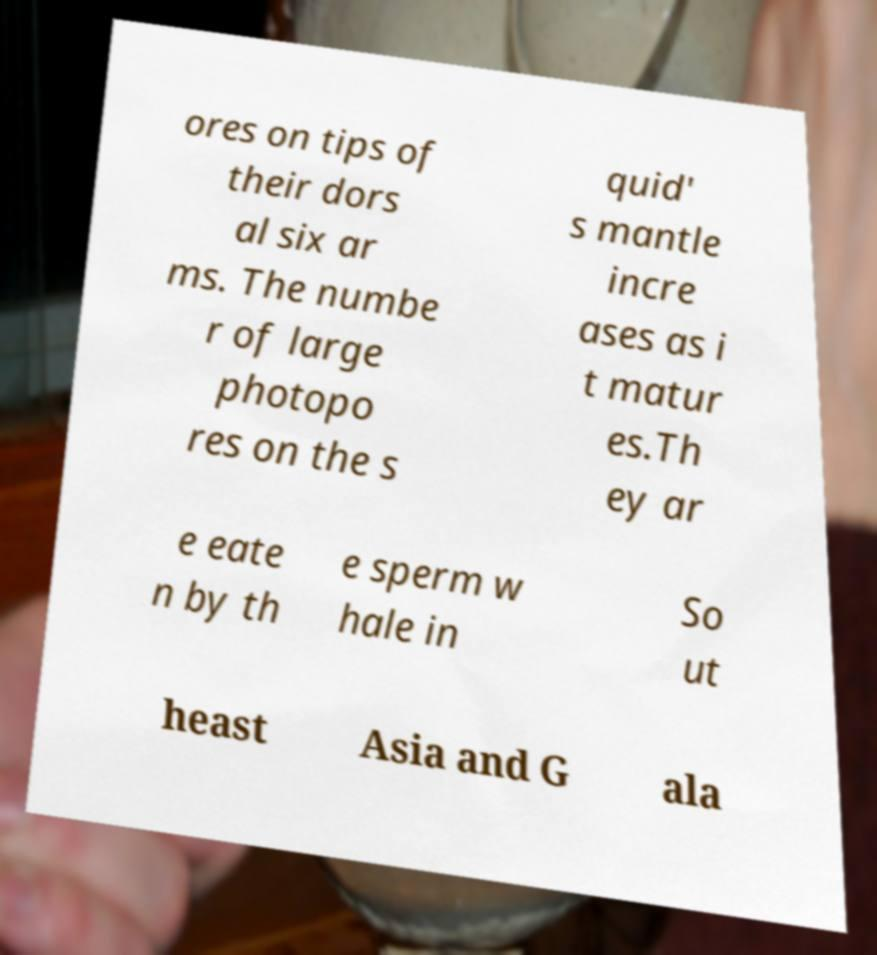Can you read and provide the text displayed in the image?This photo seems to have some interesting text. Can you extract and type it out for me? ores on tips of their dors al six ar ms. The numbe r of large photopo res on the s quid' s mantle incre ases as i t matur es.Th ey ar e eate n by th e sperm w hale in So ut heast Asia and G ala 